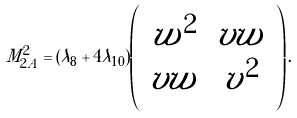Convert formula to latex. <formula><loc_0><loc_0><loc_500><loc_500>M ^ { 2 } _ { 2 A } = ( \lambda _ { 8 } + 4 \lambda _ { 1 0 } ) \left ( \begin{array} { c c } w ^ { 2 } & v w \\ v w & v ^ { 2 } \end{array} \right ) .</formula> 